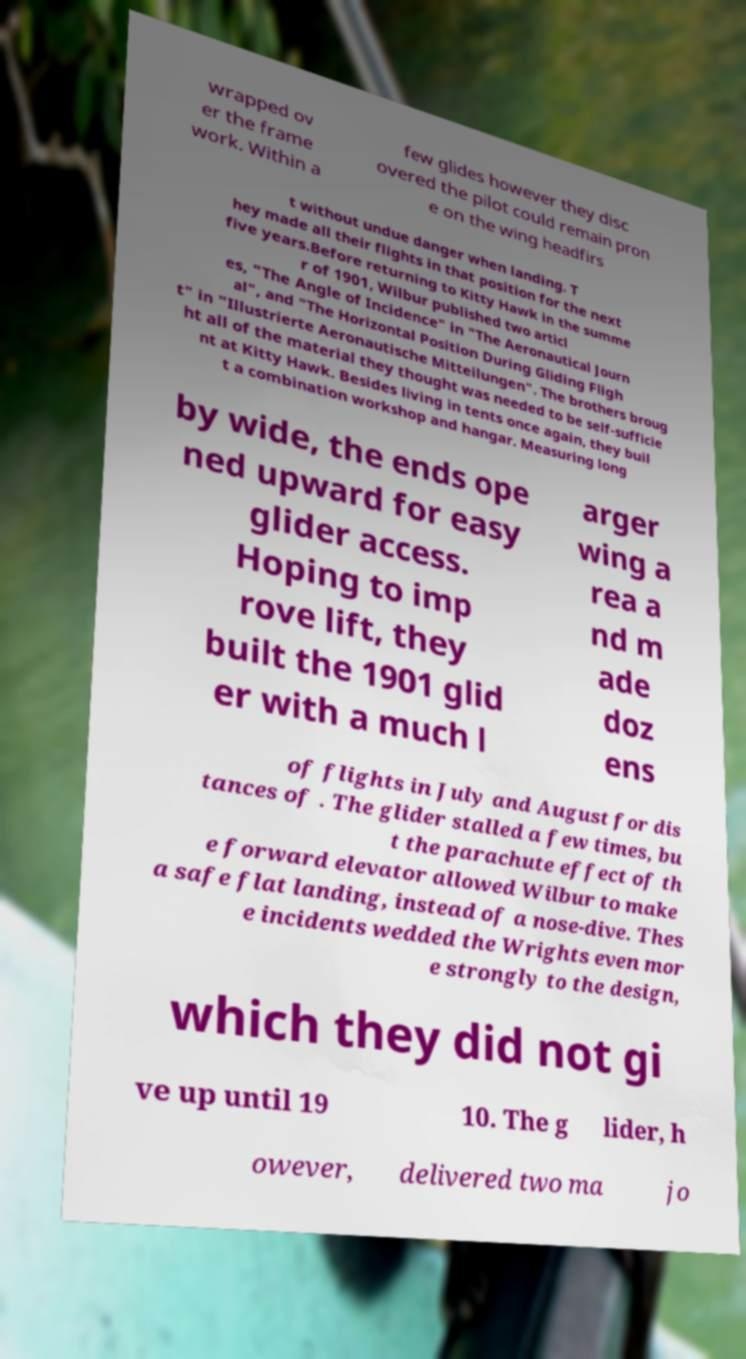Please identify and transcribe the text found in this image. wrapped ov er the frame work. Within a few glides however they disc overed the pilot could remain pron e on the wing headfirs t without undue danger when landing. T hey made all their flights in that position for the next five years.Before returning to Kitty Hawk in the summe r of 1901, Wilbur published two articl es, "The Angle of Incidence" in "The Aeronautical Journ al", and "The Horizontal Position During Gliding Fligh t" in "Illustrierte Aeronautische Mitteilungen". The brothers broug ht all of the material they thought was needed to be self-sufficie nt at Kitty Hawk. Besides living in tents once again, they buil t a combination workshop and hangar. Measuring long by wide, the ends ope ned upward for easy glider access. Hoping to imp rove lift, they built the 1901 glid er with a much l arger wing a rea a nd m ade doz ens of flights in July and August for dis tances of . The glider stalled a few times, bu t the parachute effect of th e forward elevator allowed Wilbur to make a safe flat landing, instead of a nose-dive. Thes e incidents wedded the Wrights even mor e strongly to the design, which they did not gi ve up until 19 10. The g lider, h owever, delivered two ma jo 